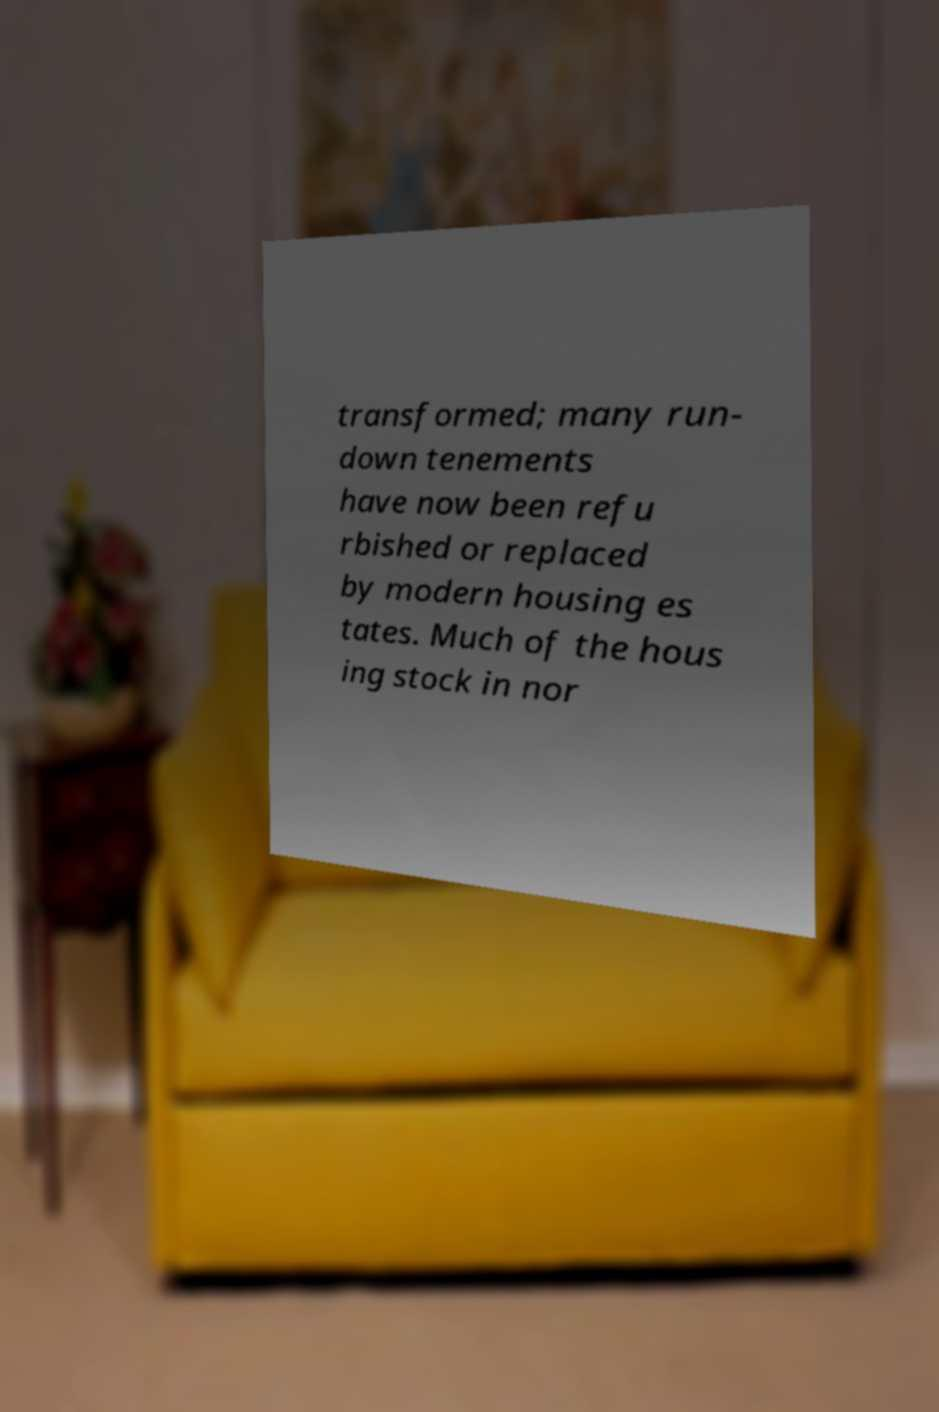Can you read and provide the text displayed in the image?This photo seems to have some interesting text. Can you extract and type it out for me? transformed; many run- down tenements have now been refu rbished or replaced by modern housing es tates. Much of the hous ing stock in nor 